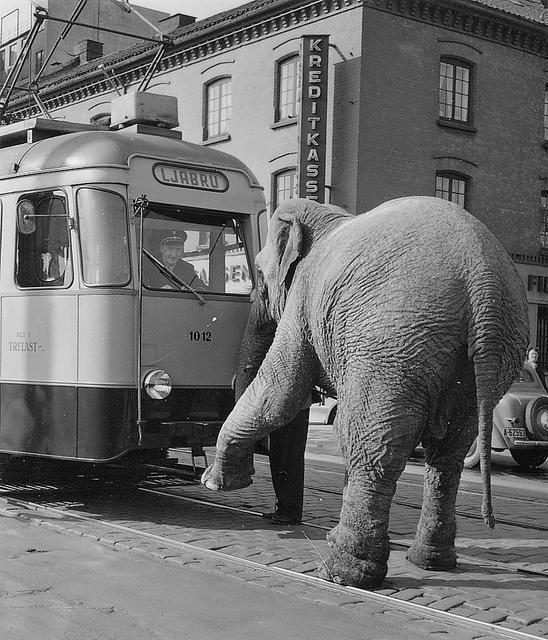Is the statement "The bus is in front of the elephant." accurate regarding the image?
Answer yes or no. Yes. Does the caption "The elephant is in front of the bus." correctly depict the image?
Answer yes or no. Yes. Is the caption "The elephant is touching the bus." a true representation of the image?
Answer yes or no. Yes. 